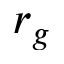<formula> <loc_0><loc_0><loc_500><loc_500>r _ { g }</formula> 